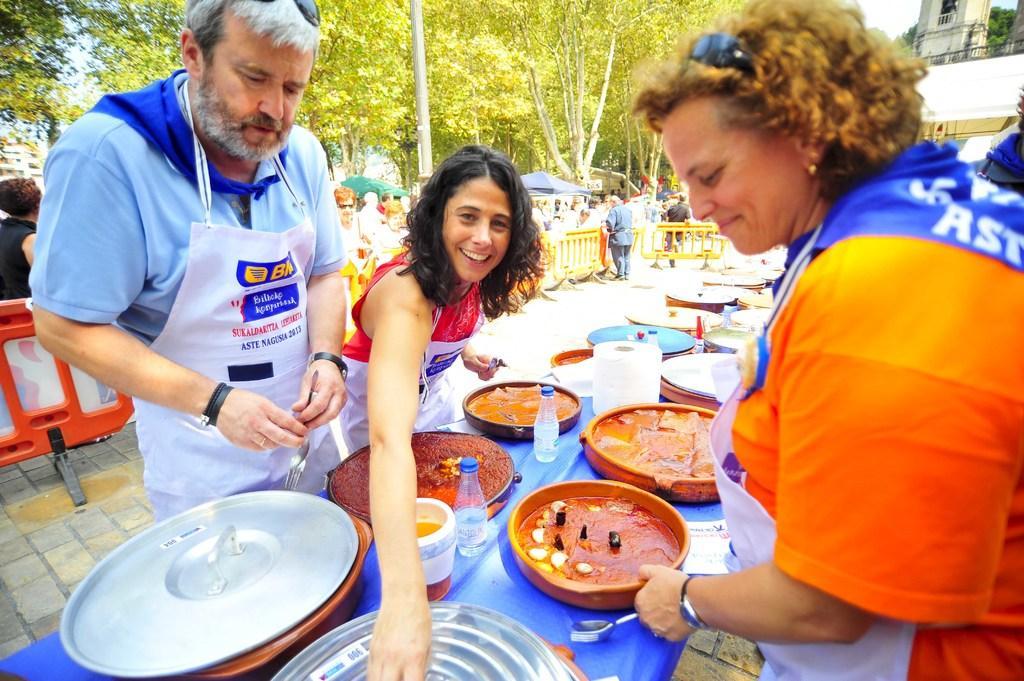Could you give a brief overview of what you see in this image? In this image we can see this people are standing near the table. We can see bottles, plates, bowls with food and tissue roll on the table. In the background we can see tents, people and trees. 